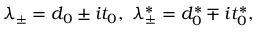Convert formula to latex. <formula><loc_0><loc_0><loc_500><loc_500>\lambda _ { \pm } = d _ { 0 } \pm i t _ { 0 } , \lambda _ { \pm } ^ { \ast } = d _ { 0 } ^ { \ast } \mp i t _ { 0 } ^ { \ast } ,</formula> 